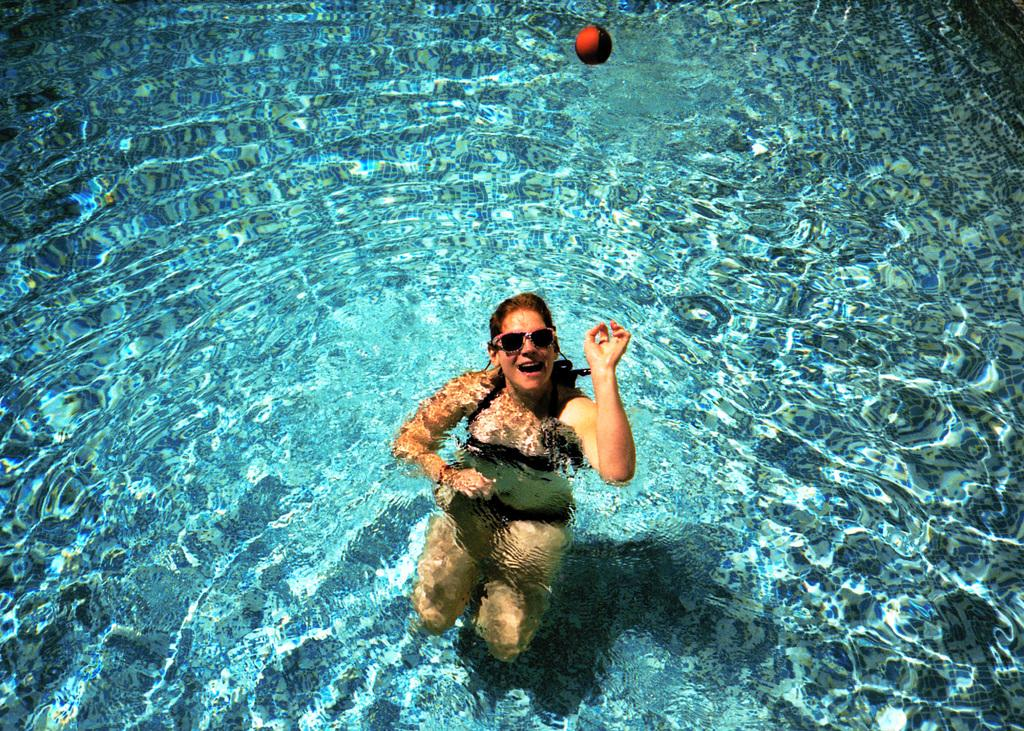What is the woman doing in the image? The woman is in a swimming pool. What is the woman wearing while in the pool? The woman is wearing spectacles. What can be seen floating in the water with the woman? There is a red color ball in the water. What type of car is parked near the swimming pool in the image? There is no car present in the image; it only features a woman in a swimming pool and a red color ball in the water. 